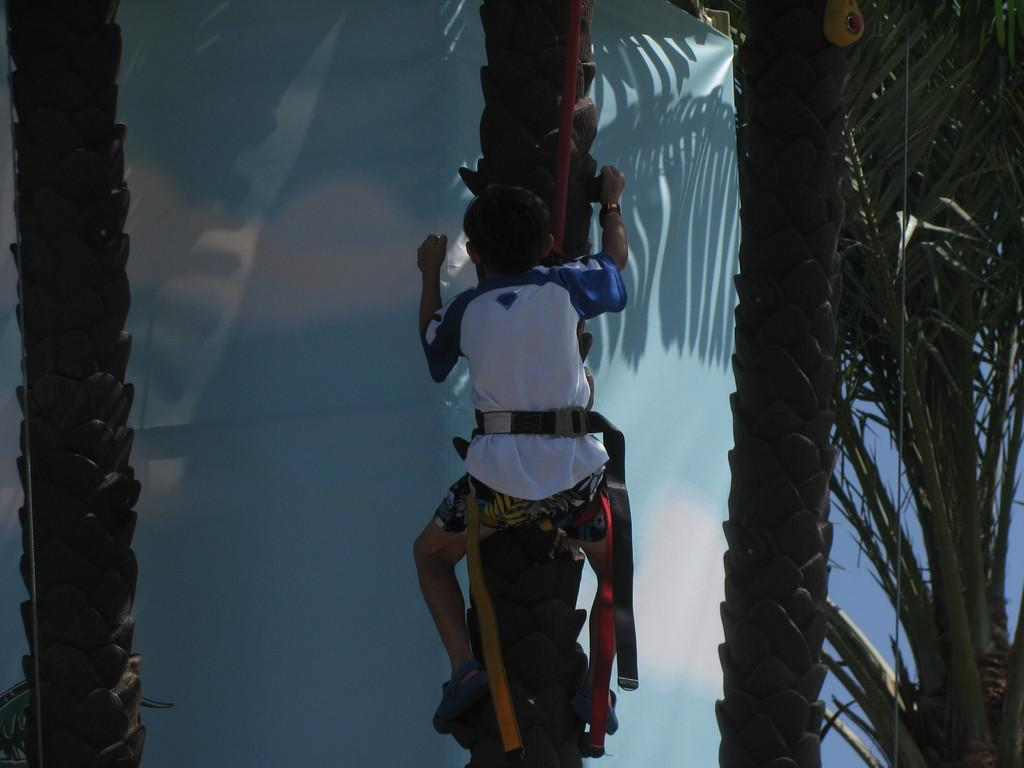What is the person in the image doing? There is a person climbing a tree in the image. What type of vegetation is present in the image? There are trees in the image. What structure can be seen in the image? There is a wall in the image. What type of waves can be seen crashing against the wall in the image? There are no waves present in the image; it features a person climbing a tree and a wall in a land-based setting. 